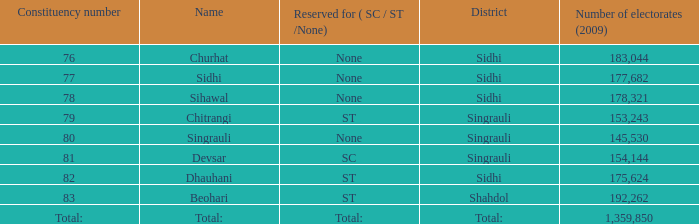What is the largest number of electorates beohari has had? 192262.0. Give me the full table as a dictionary. {'header': ['Constituency number', 'Name', 'Reserved for ( SC / ST /None)', 'District', 'Number of electorates (2009)'], 'rows': [['76', 'Churhat', 'None', 'Sidhi', '183,044'], ['77', 'Sidhi', 'None', 'Sidhi', '177,682'], ['78', 'Sihawal', 'None', 'Sidhi', '178,321'], ['79', 'Chitrangi', 'ST', 'Singrauli', '153,243'], ['80', 'Singrauli', 'None', 'Singrauli', '145,530'], ['81', 'Devsar', 'SC', 'Singrauli', '154,144'], ['82', 'Dhauhani', 'ST', 'Sidhi', '175,624'], ['83', 'Beohari', 'ST', 'Shahdol', '192,262'], ['Total:', 'Total:', 'Total:', 'Total:', '1,359,850']]} 